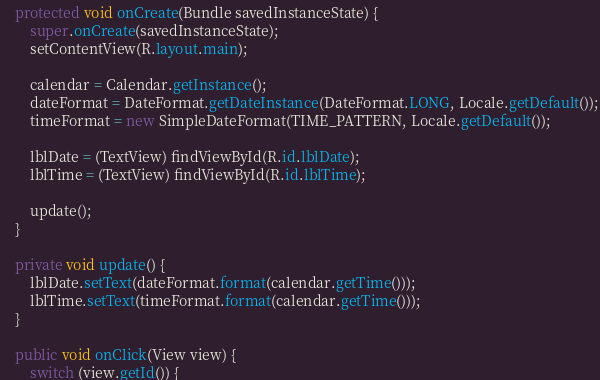Convert code to text. <code><loc_0><loc_0><loc_500><loc_500><_Java_>    protected void onCreate(Bundle savedInstanceState) {
        super.onCreate(savedInstanceState);
        setContentView(R.layout.main);

        calendar = Calendar.getInstance();
        dateFormat = DateFormat.getDateInstance(DateFormat.LONG, Locale.getDefault());
        timeFormat = new SimpleDateFormat(TIME_PATTERN, Locale.getDefault());

        lblDate = (TextView) findViewById(R.id.lblDate);
        lblTime = (TextView) findViewById(R.id.lblTime);

        update();
    }

    private void update() {
        lblDate.setText(dateFormat.format(calendar.getTime()));
        lblTime.setText(timeFormat.format(calendar.getTime()));
    }

    public void onClick(View view) {
        switch (view.getId()) {</code> 